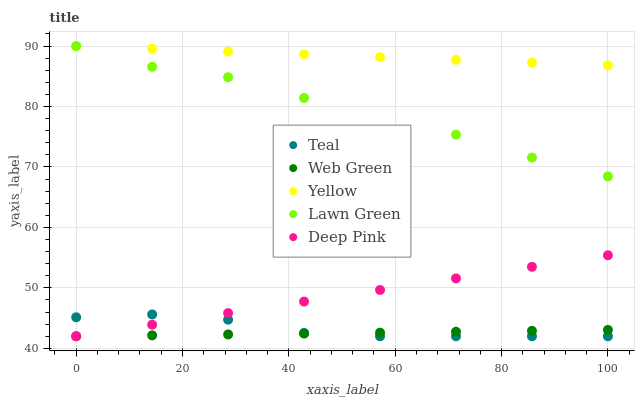Does Web Green have the minimum area under the curve?
Answer yes or no. Yes. Does Yellow have the maximum area under the curve?
Answer yes or no. Yes. Does Deep Pink have the minimum area under the curve?
Answer yes or no. No. Does Deep Pink have the maximum area under the curve?
Answer yes or no. No. Is Deep Pink the smoothest?
Answer yes or no. Yes. Is Lawn Green the roughest?
Answer yes or no. Yes. Is Yellow the smoothest?
Answer yes or no. No. Is Yellow the roughest?
Answer yes or no. No. Does Deep Pink have the lowest value?
Answer yes or no. Yes. Does Yellow have the lowest value?
Answer yes or no. No. Does Yellow have the highest value?
Answer yes or no. Yes. Does Deep Pink have the highest value?
Answer yes or no. No. Is Teal less than Lawn Green?
Answer yes or no. Yes. Is Lawn Green greater than Teal?
Answer yes or no. Yes. Does Web Green intersect Deep Pink?
Answer yes or no. Yes. Is Web Green less than Deep Pink?
Answer yes or no. No. Is Web Green greater than Deep Pink?
Answer yes or no. No. Does Teal intersect Lawn Green?
Answer yes or no. No. 